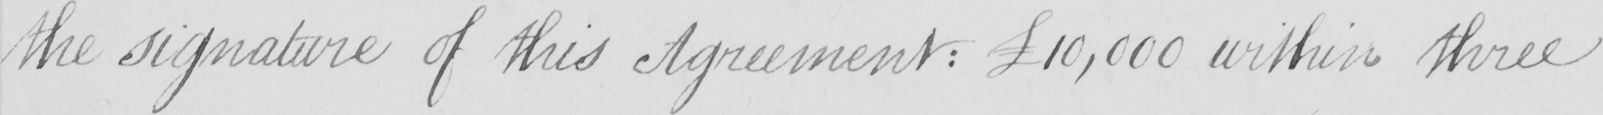What text is written in this handwritten line? the signature of this Agreement :   £10,000 within three 